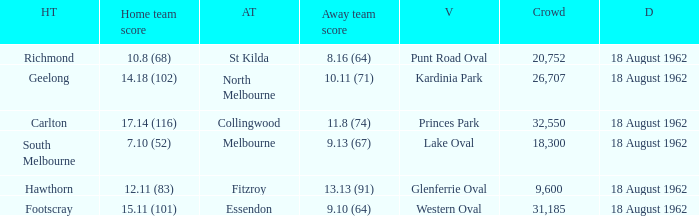What was the home team that scored 10.8 (68)? Richmond. 